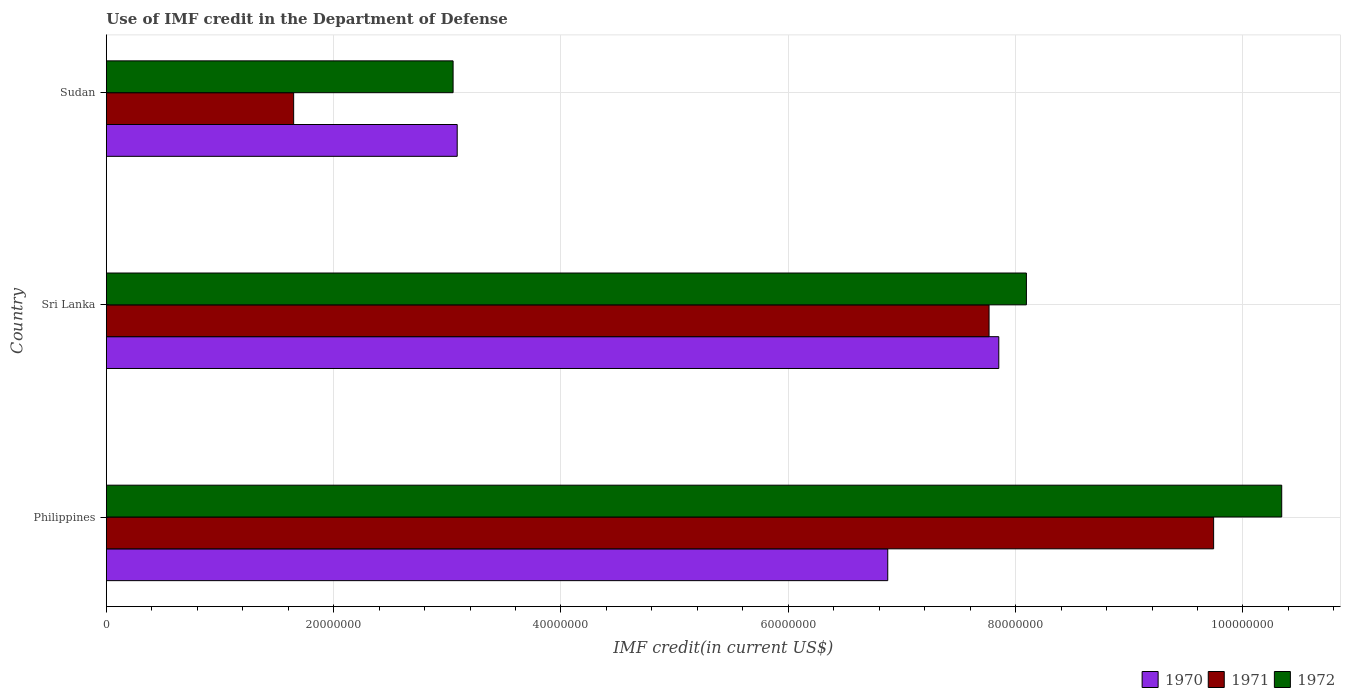How many different coloured bars are there?
Your answer should be compact. 3. How many groups of bars are there?
Provide a short and direct response. 3. Are the number of bars per tick equal to the number of legend labels?
Your answer should be compact. Yes. Are the number of bars on each tick of the Y-axis equal?
Offer a terse response. Yes. How many bars are there on the 2nd tick from the top?
Your response must be concise. 3. How many bars are there on the 1st tick from the bottom?
Make the answer very short. 3. What is the label of the 2nd group of bars from the top?
Provide a short and direct response. Sri Lanka. In how many cases, is the number of bars for a given country not equal to the number of legend labels?
Keep it short and to the point. 0. What is the IMF credit in the Department of Defense in 1970 in Philippines?
Offer a very short reply. 6.88e+07. Across all countries, what is the maximum IMF credit in the Department of Defense in 1970?
Your response must be concise. 7.85e+07. Across all countries, what is the minimum IMF credit in the Department of Defense in 1972?
Give a very brief answer. 3.05e+07. In which country was the IMF credit in the Department of Defense in 1972 maximum?
Keep it short and to the point. Philippines. In which country was the IMF credit in the Department of Defense in 1970 minimum?
Your answer should be compact. Sudan. What is the total IMF credit in the Department of Defense in 1971 in the graph?
Keep it short and to the point. 1.92e+08. What is the difference between the IMF credit in the Department of Defense in 1972 in Sri Lanka and that in Sudan?
Your answer should be compact. 5.04e+07. What is the difference between the IMF credit in the Department of Defense in 1971 in Sri Lanka and the IMF credit in the Department of Defense in 1970 in Sudan?
Provide a succinct answer. 4.68e+07. What is the average IMF credit in the Department of Defense in 1971 per country?
Offer a very short reply. 6.39e+07. What is the difference between the IMF credit in the Department of Defense in 1972 and IMF credit in the Department of Defense in 1970 in Sri Lanka?
Provide a succinct answer. 2.43e+06. What is the ratio of the IMF credit in the Department of Defense in 1970 in Philippines to that in Sri Lanka?
Provide a short and direct response. 0.88. Is the difference between the IMF credit in the Department of Defense in 1972 in Philippines and Sudan greater than the difference between the IMF credit in the Department of Defense in 1970 in Philippines and Sudan?
Offer a very short reply. Yes. What is the difference between the highest and the second highest IMF credit in the Department of Defense in 1970?
Keep it short and to the point. 9.77e+06. What is the difference between the highest and the lowest IMF credit in the Department of Defense in 1971?
Keep it short and to the point. 8.09e+07. What does the 3rd bar from the top in Philippines represents?
Make the answer very short. 1970. What does the 2nd bar from the bottom in Philippines represents?
Your answer should be very brief. 1971. Is it the case that in every country, the sum of the IMF credit in the Department of Defense in 1971 and IMF credit in the Department of Defense in 1972 is greater than the IMF credit in the Department of Defense in 1970?
Provide a short and direct response. Yes. How many bars are there?
Give a very brief answer. 9. Are all the bars in the graph horizontal?
Provide a short and direct response. Yes. How many countries are there in the graph?
Give a very brief answer. 3. Does the graph contain grids?
Offer a terse response. Yes. Where does the legend appear in the graph?
Make the answer very short. Bottom right. How are the legend labels stacked?
Keep it short and to the point. Horizontal. What is the title of the graph?
Ensure brevity in your answer.  Use of IMF credit in the Department of Defense. What is the label or title of the X-axis?
Make the answer very short. IMF credit(in current US$). What is the label or title of the Y-axis?
Offer a very short reply. Country. What is the IMF credit(in current US$) of 1970 in Philippines?
Your response must be concise. 6.88e+07. What is the IMF credit(in current US$) of 1971 in Philippines?
Your response must be concise. 9.74e+07. What is the IMF credit(in current US$) in 1972 in Philippines?
Offer a terse response. 1.03e+08. What is the IMF credit(in current US$) of 1970 in Sri Lanka?
Offer a terse response. 7.85e+07. What is the IMF credit(in current US$) of 1971 in Sri Lanka?
Offer a very short reply. 7.77e+07. What is the IMF credit(in current US$) in 1972 in Sri Lanka?
Make the answer very short. 8.10e+07. What is the IMF credit(in current US$) in 1970 in Sudan?
Your answer should be very brief. 3.09e+07. What is the IMF credit(in current US$) in 1971 in Sudan?
Provide a short and direct response. 1.65e+07. What is the IMF credit(in current US$) in 1972 in Sudan?
Provide a short and direct response. 3.05e+07. Across all countries, what is the maximum IMF credit(in current US$) of 1970?
Your answer should be very brief. 7.85e+07. Across all countries, what is the maximum IMF credit(in current US$) in 1971?
Offer a terse response. 9.74e+07. Across all countries, what is the maximum IMF credit(in current US$) of 1972?
Make the answer very short. 1.03e+08. Across all countries, what is the minimum IMF credit(in current US$) of 1970?
Your response must be concise. 3.09e+07. Across all countries, what is the minimum IMF credit(in current US$) in 1971?
Offer a very short reply. 1.65e+07. Across all countries, what is the minimum IMF credit(in current US$) of 1972?
Your response must be concise. 3.05e+07. What is the total IMF credit(in current US$) of 1970 in the graph?
Give a very brief answer. 1.78e+08. What is the total IMF credit(in current US$) in 1971 in the graph?
Ensure brevity in your answer.  1.92e+08. What is the total IMF credit(in current US$) in 1972 in the graph?
Your response must be concise. 2.15e+08. What is the difference between the IMF credit(in current US$) of 1970 in Philippines and that in Sri Lanka?
Ensure brevity in your answer.  -9.77e+06. What is the difference between the IMF credit(in current US$) in 1971 in Philippines and that in Sri Lanka?
Provide a short and direct response. 1.98e+07. What is the difference between the IMF credit(in current US$) of 1972 in Philippines and that in Sri Lanka?
Provide a short and direct response. 2.25e+07. What is the difference between the IMF credit(in current US$) in 1970 in Philippines and that in Sudan?
Offer a very short reply. 3.79e+07. What is the difference between the IMF credit(in current US$) of 1971 in Philippines and that in Sudan?
Provide a succinct answer. 8.09e+07. What is the difference between the IMF credit(in current US$) of 1972 in Philippines and that in Sudan?
Your answer should be very brief. 7.29e+07. What is the difference between the IMF credit(in current US$) of 1970 in Sri Lanka and that in Sudan?
Your answer should be very brief. 4.76e+07. What is the difference between the IMF credit(in current US$) of 1971 in Sri Lanka and that in Sudan?
Provide a succinct answer. 6.12e+07. What is the difference between the IMF credit(in current US$) in 1972 in Sri Lanka and that in Sudan?
Offer a very short reply. 5.04e+07. What is the difference between the IMF credit(in current US$) of 1970 in Philippines and the IMF credit(in current US$) of 1971 in Sri Lanka?
Provide a short and direct response. -8.91e+06. What is the difference between the IMF credit(in current US$) of 1970 in Philippines and the IMF credit(in current US$) of 1972 in Sri Lanka?
Provide a short and direct response. -1.22e+07. What is the difference between the IMF credit(in current US$) in 1971 in Philippines and the IMF credit(in current US$) in 1972 in Sri Lanka?
Provide a short and direct response. 1.65e+07. What is the difference between the IMF credit(in current US$) of 1970 in Philippines and the IMF credit(in current US$) of 1971 in Sudan?
Keep it short and to the point. 5.23e+07. What is the difference between the IMF credit(in current US$) in 1970 in Philippines and the IMF credit(in current US$) in 1972 in Sudan?
Offer a terse response. 3.82e+07. What is the difference between the IMF credit(in current US$) in 1971 in Philippines and the IMF credit(in current US$) in 1972 in Sudan?
Your response must be concise. 6.69e+07. What is the difference between the IMF credit(in current US$) in 1970 in Sri Lanka and the IMF credit(in current US$) in 1971 in Sudan?
Offer a terse response. 6.20e+07. What is the difference between the IMF credit(in current US$) of 1970 in Sri Lanka and the IMF credit(in current US$) of 1972 in Sudan?
Make the answer very short. 4.80e+07. What is the difference between the IMF credit(in current US$) of 1971 in Sri Lanka and the IMF credit(in current US$) of 1972 in Sudan?
Your answer should be compact. 4.72e+07. What is the average IMF credit(in current US$) in 1970 per country?
Your answer should be very brief. 5.94e+07. What is the average IMF credit(in current US$) in 1971 per country?
Ensure brevity in your answer.  6.39e+07. What is the average IMF credit(in current US$) of 1972 per country?
Your response must be concise. 7.16e+07. What is the difference between the IMF credit(in current US$) of 1970 and IMF credit(in current US$) of 1971 in Philippines?
Your answer should be compact. -2.87e+07. What is the difference between the IMF credit(in current US$) in 1970 and IMF credit(in current US$) in 1972 in Philippines?
Offer a terse response. -3.47e+07. What is the difference between the IMF credit(in current US$) in 1971 and IMF credit(in current US$) in 1972 in Philippines?
Your answer should be very brief. -5.99e+06. What is the difference between the IMF credit(in current US$) in 1970 and IMF credit(in current US$) in 1971 in Sri Lanka?
Offer a terse response. 8.56e+05. What is the difference between the IMF credit(in current US$) of 1970 and IMF credit(in current US$) of 1972 in Sri Lanka?
Provide a short and direct response. -2.43e+06. What is the difference between the IMF credit(in current US$) of 1971 and IMF credit(in current US$) of 1972 in Sri Lanka?
Your answer should be compact. -3.29e+06. What is the difference between the IMF credit(in current US$) of 1970 and IMF credit(in current US$) of 1971 in Sudan?
Give a very brief answer. 1.44e+07. What is the difference between the IMF credit(in current US$) of 1970 and IMF credit(in current US$) of 1972 in Sudan?
Your answer should be compact. 3.62e+05. What is the difference between the IMF credit(in current US$) of 1971 and IMF credit(in current US$) of 1972 in Sudan?
Make the answer very short. -1.40e+07. What is the ratio of the IMF credit(in current US$) in 1970 in Philippines to that in Sri Lanka?
Your answer should be compact. 0.88. What is the ratio of the IMF credit(in current US$) of 1971 in Philippines to that in Sri Lanka?
Your response must be concise. 1.25. What is the ratio of the IMF credit(in current US$) of 1972 in Philippines to that in Sri Lanka?
Make the answer very short. 1.28. What is the ratio of the IMF credit(in current US$) in 1970 in Philippines to that in Sudan?
Ensure brevity in your answer.  2.23. What is the ratio of the IMF credit(in current US$) in 1971 in Philippines to that in Sudan?
Ensure brevity in your answer.  5.91. What is the ratio of the IMF credit(in current US$) in 1972 in Philippines to that in Sudan?
Make the answer very short. 3.39. What is the ratio of the IMF credit(in current US$) of 1970 in Sri Lanka to that in Sudan?
Your response must be concise. 2.54. What is the ratio of the IMF credit(in current US$) of 1971 in Sri Lanka to that in Sudan?
Your response must be concise. 4.71. What is the ratio of the IMF credit(in current US$) of 1972 in Sri Lanka to that in Sudan?
Provide a short and direct response. 2.65. What is the difference between the highest and the second highest IMF credit(in current US$) of 1970?
Make the answer very short. 9.77e+06. What is the difference between the highest and the second highest IMF credit(in current US$) in 1971?
Your response must be concise. 1.98e+07. What is the difference between the highest and the second highest IMF credit(in current US$) of 1972?
Provide a short and direct response. 2.25e+07. What is the difference between the highest and the lowest IMF credit(in current US$) of 1970?
Offer a terse response. 4.76e+07. What is the difference between the highest and the lowest IMF credit(in current US$) of 1971?
Provide a short and direct response. 8.09e+07. What is the difference between the highest and the lowest IMF credit(in current US$) in 1972?
Provide a short and direct response. 7.29e+07. 